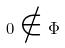Convert formula to latex. <formula><loc_0><loc_0><loc_500><loc_500>0 \notin \Phi</formula> 